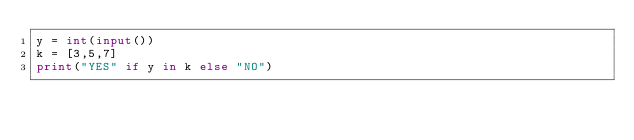<code> <loc_0><loc_0><loc_500><loc_500><_Python_>y = int(input())
k = [3,5,7]
print("YES" if y in k else "NO")</code> 